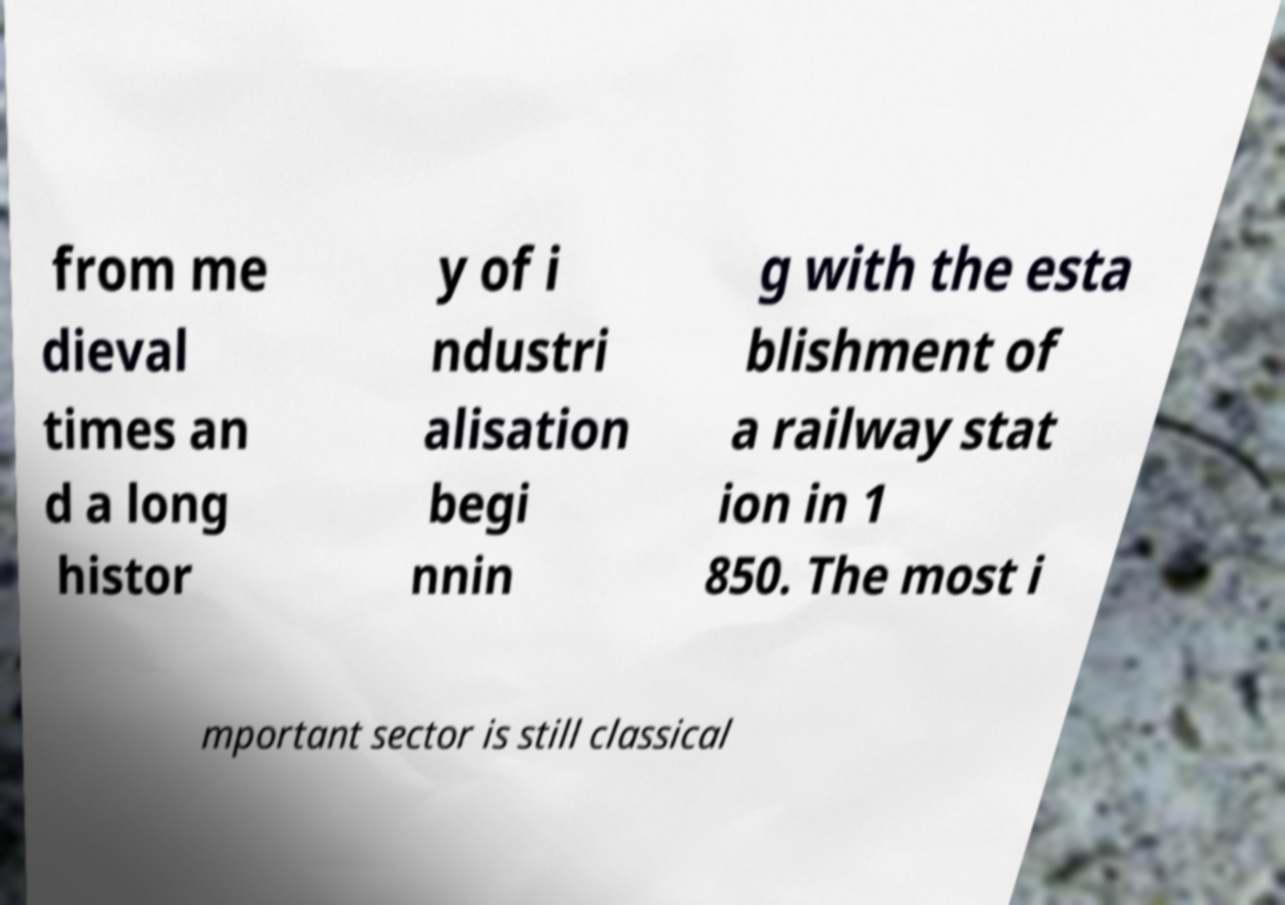For documentation purposes, I need the text within this image transcribed. Could you provide that? from me dieval times an d a long histor y of i ndustri alisation begi nnin g with the esta blishment of a railway stat ion in 1 850. The most i mportant sector is still classical 